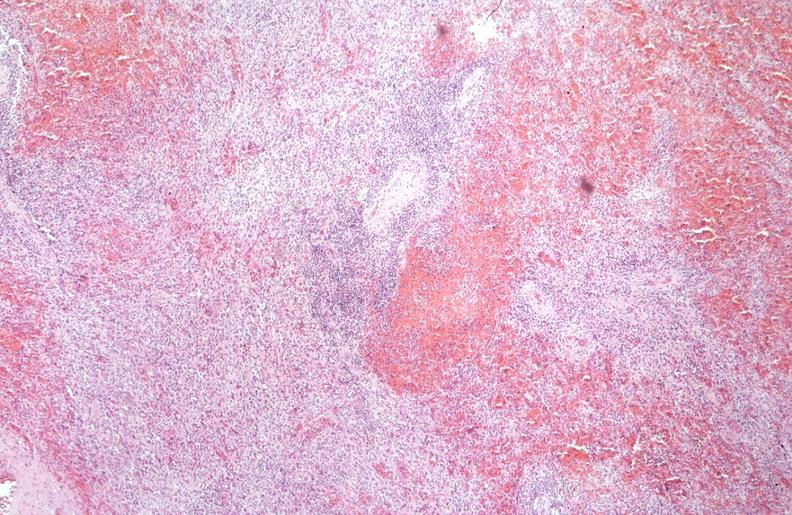s hematologic present?
Answer the question using a single word or phrase. Yes 